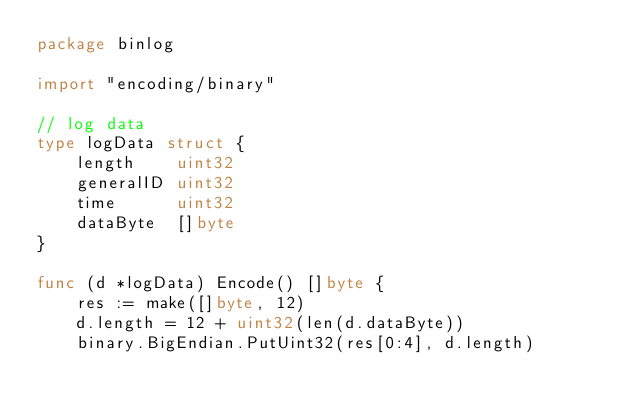Convert code to text. <code><loc_0><loc_0><loc_500><loc_500><_Go_>package binlog

import "encoding/binary"

// log data
type logData struct {
	length    uint32
	generalID uint32
	time      uint32
	dataByte  []byte
}

func (d *logData) Encode() []byte {
	res := make([]byte, 12)
	d.length = 12 + uint32(len(d.dataByte))
	binary.BigEndian.PutUint32(res[0:4], d.length)</code> 